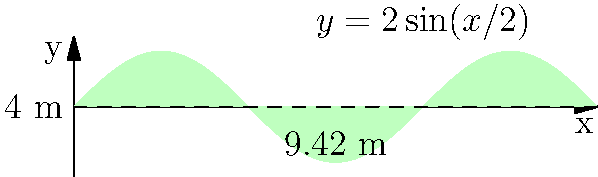A noise-canceling barrier is being designed for a residential area near a busy highway. The barrier's cross-section follows the curve $y = 2\sin(x/2)$ from $x = 0$ to $x = 6\pi$ meters, with a height of 4 meters. Calculate the total surface area of the barrier if it extends for 100 meters along the highway. Round your answer to the nearest square meter. To calculate the surface area of the noise-canceling barrier, we need to follow these steps:

1) First, we need to calculate the length of the curved part of the cross-section. This can be done using the arc length formula:

   $L = \int_0^{6\pi} \sqrt{1 + [f'(x)]^2} dx$

   Where $f(x) = 2\sin(x/2)$, so $f'(x) = \cos(x/2)$

2) Substituting this into the formula:

   $L = \int_0^{6\pi} \sqrt{1 + [\cos(x/2)]^2} dx$

3) This integral doesn't have a simple analytical solution, so we would typically use numerical methods to evaluate it. Using a calculator or computer, we find that $L \approx 9.90$ meters.

4) The cross-sectional area of the barrier consists of this curved part (9.90 m) and the straight vertical part (4 m), totaling approximately 13.90 meters.

5) Since the barrier extends for 100 meters along the highway, the total surface area is:

   Surface Area = 13.90 m × 100 m = 1390 square meters

6) Rounding to the nearest square meter gives us 1390 square meters.
Answer: 1390 square meters 